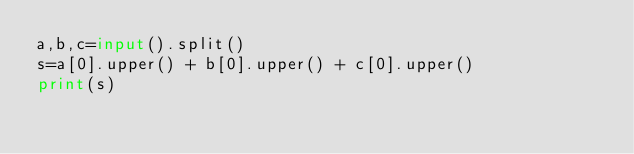<code> <loc_0><loc_0><loc_500><loc_500><_Python_>a,b,c=input().split()
s=a[0].upper() + b[0].upper() + c[0].upper()
print(s)</code> 